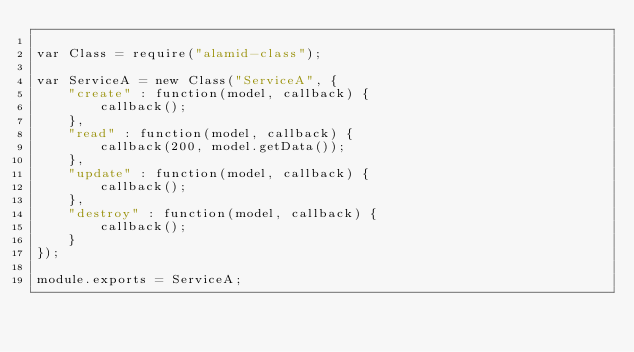Convert code to text. <code><loc_0><loc_0><loc_500><loc_500><_JavaScript_>
var Class = require("alamid-class");

var ServiceA = new Class("ServiceA", {
    "create" : function(model, callback) {
        callback();
    },
    "read" : function(model, callback) {
        callback(200, model.getData());
    },
    "update" : function(model, callback) {
        callback();
    },
    "destroy" : function(model, callback) {
        callback();
    }
});

module.exports = ServiceA;


</code> 